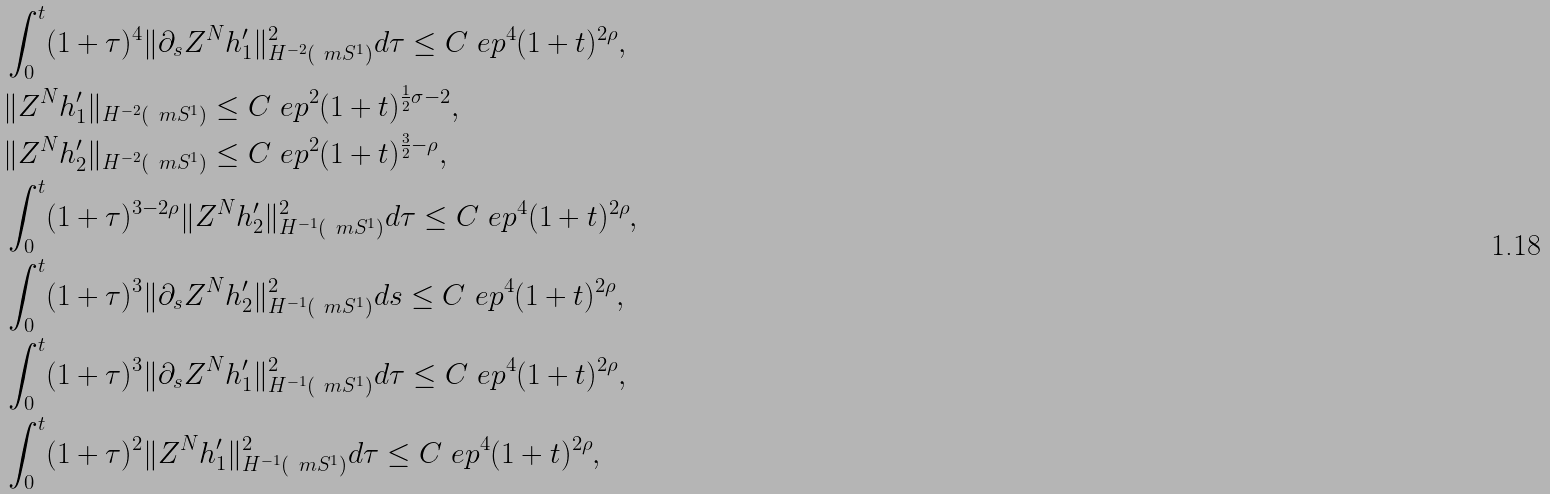Convert formula to latex. <formula><loc_0><loc_0><loc_500><loc_500>& \int _ { 0 } ^ { t } ( 1 + \tau ) ^ { 4 } \| \partial _ { s } Z ^ { N } h ^ { \prime } _ { 1 } \| _ { H ^ { - 2 } ( \ m S ^ { 1 } ) } ^ { 2 } d \tau \leq C \ e p ^ { 4 } ( 1 + t ) ^ { 2 \rho } , \\ & \| Z ^ { N } h ^ { \prime } _ { 1 } \| _ { H ^ { - 2 } ( \ m S ^ { 1 } ) } \leq C \ e p ^ { 2 } ( 1 + t ) ^ { \frac { 1 } { 2 } \sigma - 2 } , \\ & \| Z ^ { N } h ^ { \prime } _ { 2 } \| _ { H ^ { - 2 } ( \ m S ^ { 1 } ) } \leq C \ e p ^ { 2 } ( 1 + t ) ^ { \frac { 3 } { 2 } - \rho } , \\ & \int _ { 0 } ^ { t } ( 1 + \tau ) ^ { 3 - 2 \rho } \| Z ^ { N } h ^ { \prime } _ { 2 } \| _ { H ^ { - 1 } ( \ m S ^ { 1 } ) } ^ { 2 } d \tau \leq C \ e p ^ { 4 } ( 1 + t ) ^ { 2 \rho } , \\ & \int _ { 0 } ^ { t } ( 1 + \tau ) ^ { 3 } \| \partial _ { s } Z ^ { N } h ^ { \prime } _ { 2 } \| _ { H ^ { - 1 } ( \ m S ^ { 1 } ) } ^ { 2 } d s \leq C \ e p ^ { 4 } ( 1 + t ) ^ { 2 \rho } , \\ & \int _ { 0 } ^ { t } ( 1 + \tau ) ^ { 3 } \| \partial _ { s } Z ^ { N } h ^ { \prime } _ { 1 } \| _ { H ^ { - 1 } ( \ m S ^ { 1 } ) } ^ { 2 } d \tau \leq C \ e p ^ { 4 } ( 1 + t ) ^ { 2 \rho } , \\ & \int _ { 0 } ^ { t } ( 1 + \tau ) ^ { 2 } \| Z ^ { N } h ^ { \prime } _ { 1 } \| _ { H ^ { - 1 } ( \ m S ^ { 1 } ) } ^ { 2 } d \tau \leq C \ e p ^ { 4 } ( 1 + t ) ^ { 2 \rho } ,</formula> 